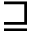<formula> <loc_0><loc_0><loc_500><loc_500>\sqsupseteq</formula> 